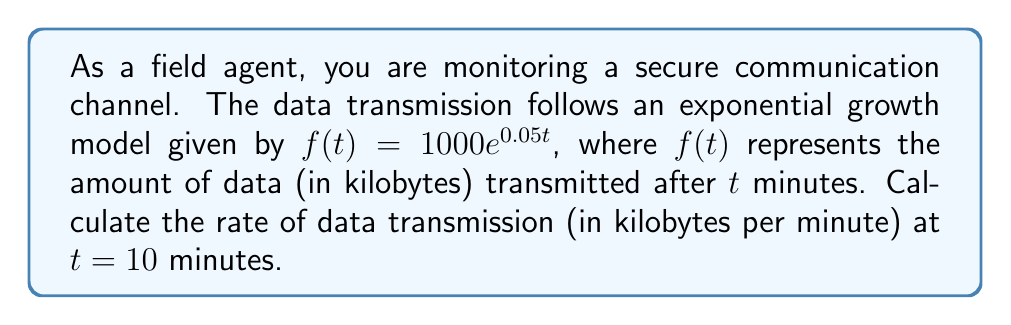Solve this math problem. To find the rate of data transmission at a specific time, we need to calculate the derivative of the given function and evaluate it at the specified time.

1. Given function: $f(t) = 1000e^{0.05t}$

2. To find the derivative, we use the chain rule:
   $$\frac{d}{dt}[f(t)] = 1000 \cdot \frac{d}{dt}[e^{0.05t}]$$
   $$f'(t) = 1000 \cdot 0.05 \cdot e^{0.05t}$$
   $$f'(t) = 50e^{0.05t}$$

3. The derivative $f'(t)$ represents the rate of change of data transmission at any time $t$.

4. To find the rate at $t = 10$ minutes, we substitute $t = 10$ into $f'(t)$:
   $$f'(10) = 50e^{0.05 \cdot 10}$$
   $$f'(10) = 50e^{0.5}$$
   $$f'(10) = 50 \cdot 1.6487$$
   $$f'(10) \approx 82.4353$$

5. Round to two decimal places for practical use.
Answer: $82.44$ kilobytes per minute 